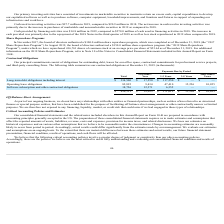According to Cornerstone Ondemand's financial document, What are the company's principal commitments? obligations for outstanding debt, leases for our office space, contractual commitments for professional service projects, and third-party consulting firms.. The document states: "Our principal commitments consist of obligations for outstanding debt, leases for our office space, contractual commitments for professional service p..." Also, What were the operating lease obligations for periods more than 5 years? According to the financial document, 10,825 (in thousands). The relevant text states: "ting lease obligations 82,895 9,434 47,410 15,226 10,825..." Also, What was the software subscription and other contractual obligations for periods less than 1 year? According to the financial document, 12,371 (in thousands). The relevant text states: "cription and other contractual obligations 18,726 12,371 6,355 — —..." Also, can you calculate: What is the sum of total operating lease obligations and Long-term debt obligations including interest? Based on the calculation: 82,895+$334,500, the result is 417395 (in thousands). This is based on the information: "Long-term debt obligations including interest $ 334,500 $ 17,250 $ 317,250 $ — $ — Operating lease obligations 82,895 9,434 47,410 15,226 10,825..." The key data points involved are: 334,500, 82,895. Also, can you calculate: What is the percentage of the total obligations that consists of software subscription and other contractual obligations? Based on the calculation: (18,726/436,121), the result is 4.29 (percentage). This is based on the information: "$ 436,121 $ 39,055 $ 371,015 $ 15,226 $ 10,825 re subscription and other contractual obligations 18,726 12,371 6,355 — —..." The key data points involved are: 18,726, 436,121. Also, can you calculate: What is the percentage of the total obligations that consists of payments due in 1-3 years? Based on the calculation: (371,015/436,121), the result is 85.07 (percentage). This is based on the information: "$ 436,121 $ 39,055 $ 371,015 $ 15,226 $ 10,825 $ 436,121 $ 39,055 $ 371,015 $ 15,226 $ 10,825..." The key data points involved are: 371,015, 436,121. 